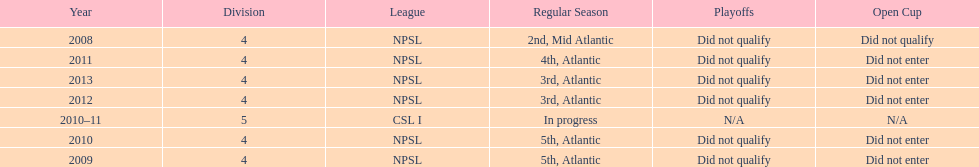How did they place the year after they were 4th in the regular season? 3rd. 